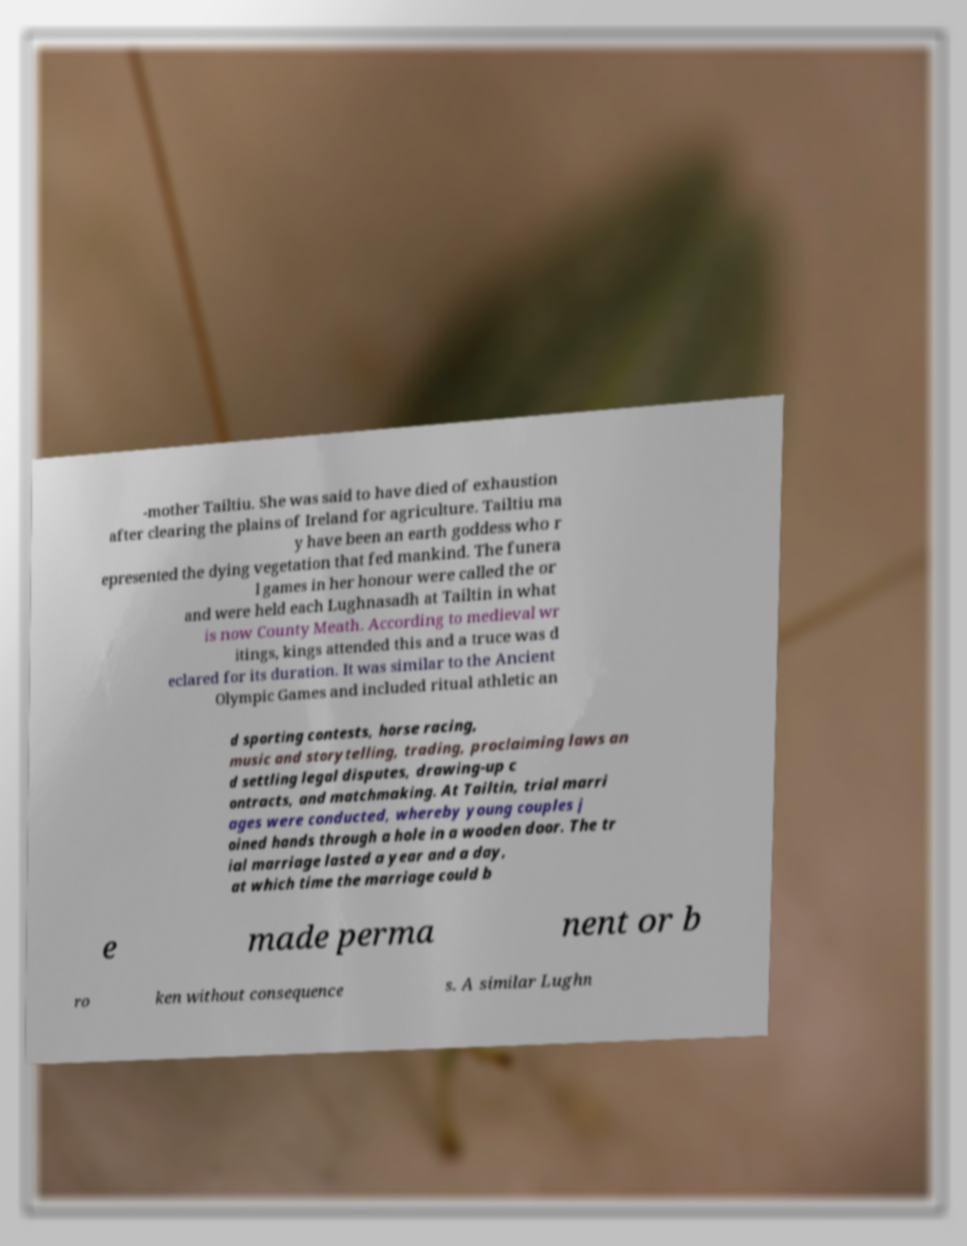Could you extract and type out the text from this image? -mother Tailtiu. She was said to have died of exhaustion after clearing the plains of Ireland for agriculture. Tailtiu ma y have been an earth goddess who r epresented the dying vegetation that fed mankind. The funera l games in her honour were called the or and were held each Lughnasadh at Tailtin in what is now County Meath. According to medieval wr itings, kings attended this and a truce was d eclared for its duration. It was similar to the Ancient Olympic Games and included ritual athletic an d sporting contests, horse racing, music and storytelling, trading, proclaiming laws an d settling legal disputes, drawing-up c ontracts, and matchmaking. At Tailtin, trial marri ages were conducted, whereby young couples j oined hands through a hole in a wooden door. The tr ial marriage lasted a year and a day, at which time the marriage could b e made perma nent or b ro ken without consequence s. A similar Lughn 